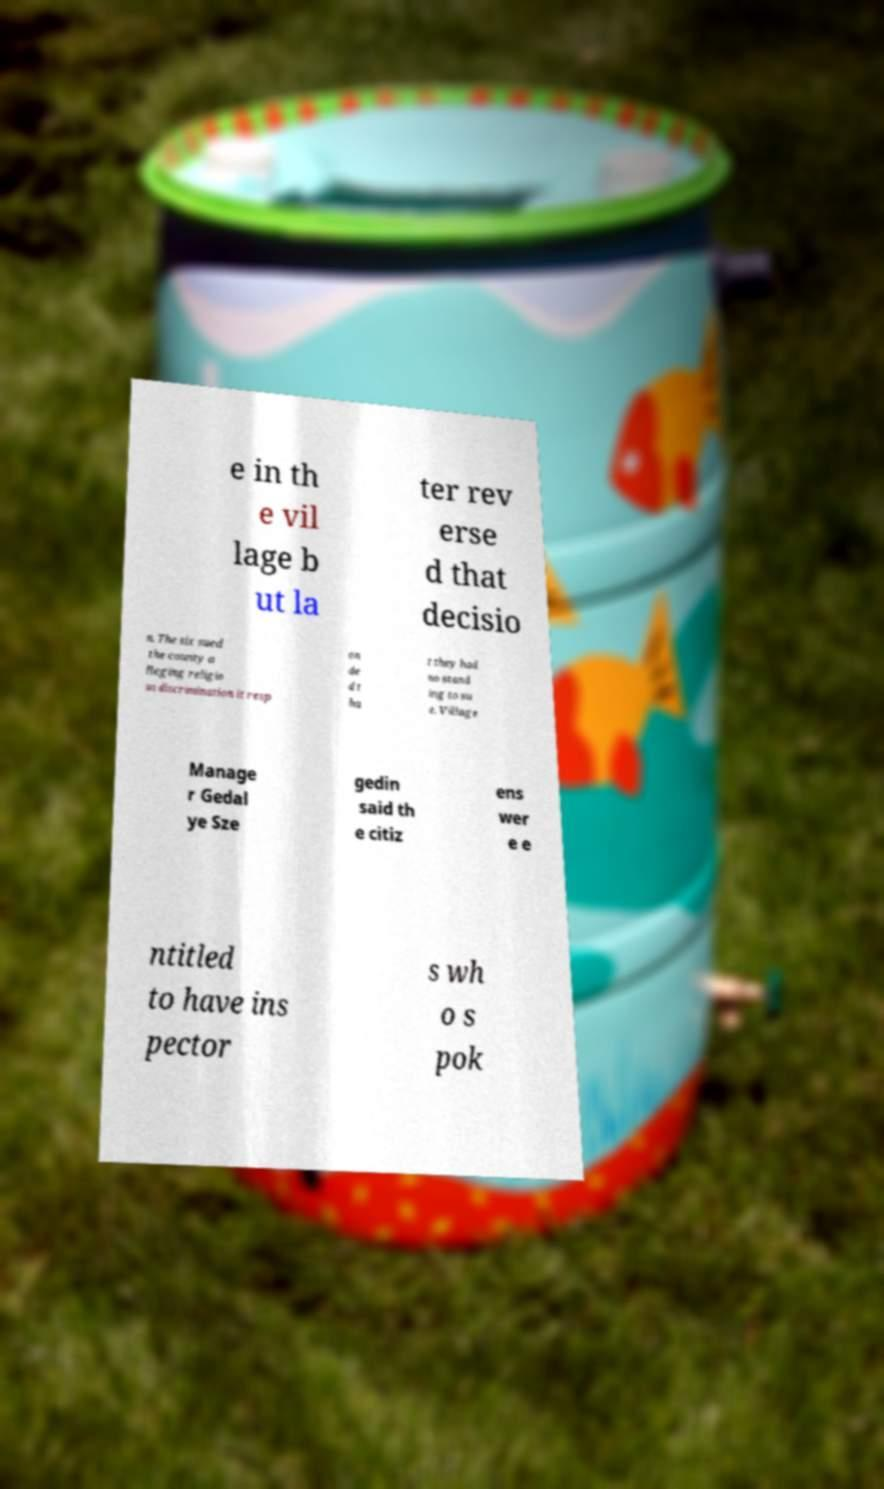Could you extract and type out the text from this image? e in th e vil lage b ut la ter rev erse d that decisio n. The six sued the county a lleging religio us discrimination it resp on de d t ha t they had no stand ing to su e. Village Manage r Gedal ye Sze gedin said th e citiz ens wer e e ntitled to have ins pector s wh o s pok 